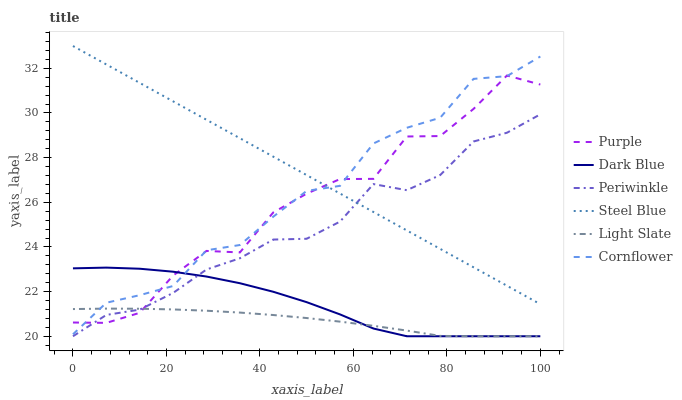Does Light Slate have the minimum area under the curve?
Answer yes or no. Yes. Does Steel Blue have the maximum area under the curve?
Answer yes or no. Yes. Does Purple have the minimum area under the curve?
Answer yes or no. No. Does Purple have the maximum area under the curve?
Answer yes or no. No. Is Steel Blue the smoothest?
Answer yes or no. Yes. Is Purple the roughest?
Answer yes or no. Yes. Is Purple the smoothest?
Answer yes or no. No. Is Steel Blue the roughest?
Answer yes or no. No. Does Light Slate have the lowest value?
Answer yes or no. Yes. Does Purple have the lowest value?
Answer yes or no. No. Does Steel Blue have the highest value?
Answer yes or no. Yes. Does Purple have the highest value?
Answer yes or no. No. Is Light Slate less than Steel Blue?
Answer yes or no. Yes. Is Steel Blue greater than Dark Blue?
Answer yes or no. Yes. Does Periwinkle intersect Light Slate?
Answer yes or no. Yes. Is Periwinkle less than Light Slate?
Answer yes or no. No. Is Periwinkle greater than Light Slate?
Answer yes or no. No. Does Light Slate intersect Steel Blue?
Answer yes or no. No. 